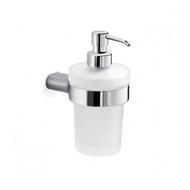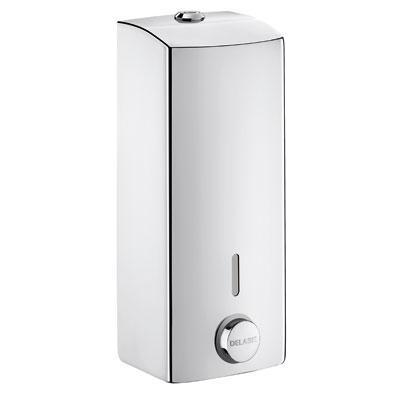The first image is the image on the left, the second image is the image on the right. For the images shown, is this caption "The cylindrical dispenser in one of the images has a thin tube on the spout." true? Answer yes or no. Yes. 